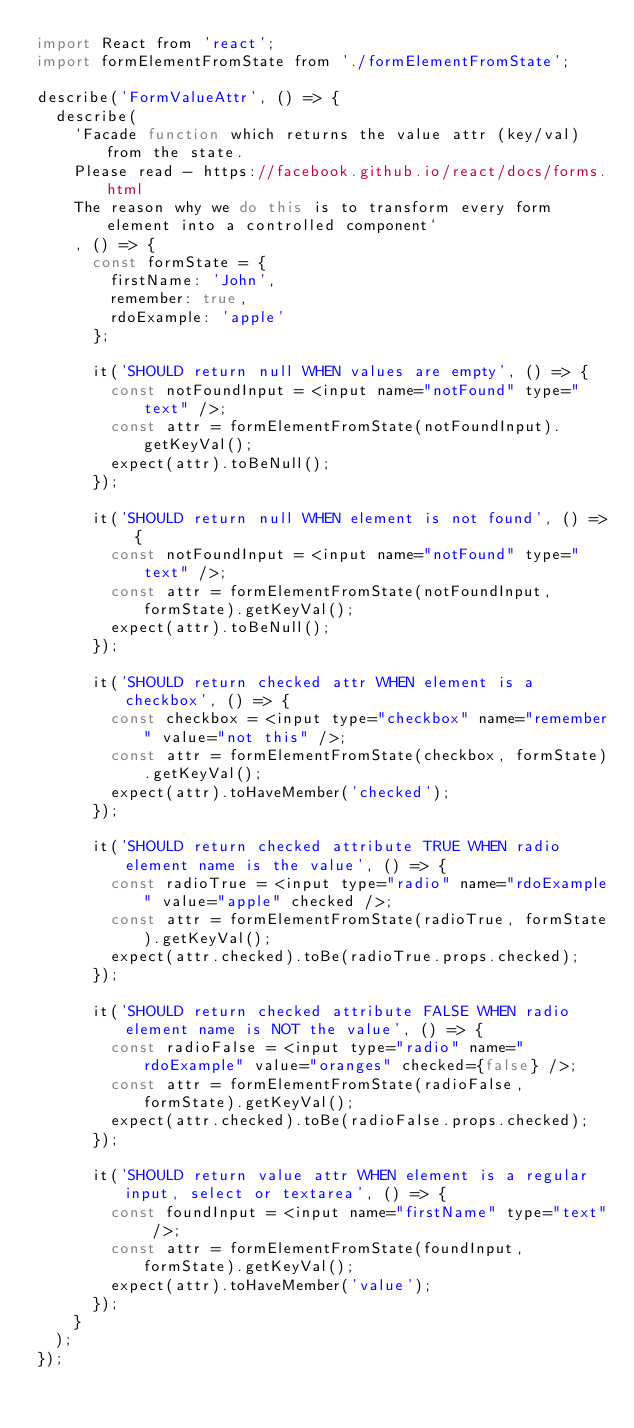<code> <loc_0><loc_0><loc_500><loc_500><_JavaScript_>import React from 'react';
import formElementFromState from './formElementFromState';

describe('FormValueAttr', () => {
  describe(
    `Facade function which returns the value attr (key/val) from the state.
    Please read - https://facebook.github.io/react/docs/forms.html
    The reason why we do this is to transform every form element into a controlled component`
    , () => {
      const formState = {
        firstName: 'John',
        remember: true,
        rdoExample: 'apple'
      };

      it('SHOULD return null WHEN values are empty', () => {
        const notFoundInput = <input name="notFound" type="text" />;
        const attr = formElementFromState(notFoundInput).getKeyVal();
        expect(attr).toBeNull();
      });

      it('SHOULD return null WHEN element is not found', () => {
        const notFoundInput = <input name="notFound" type="text" />;
        const attr = formElementFromState(notFoundInput, formState).getKeyVal();
        expect(attr).toBeNull();
      });

      it('SHOULD return checked attr WHEN element is a checkbox', () => {
        const checkbox = <input type="checkbox" name="remember" value="not this" />;
        const attr = formElementFromState(checkbox, formState).getKeyVal();
        expect(attr).toHaveMember('checked');
      });

      it('SHOULD return checked attribute TRUE WHEN radio element name is the value', () => {
        const radioTrue = <input type="radio" name="rdoExample" value="apple" checked />;
        const attr = formElementFromState(radioTrue, formState).getKeyVal();
        expect(attr.checked).toBe(radioTrue.props.checked);
      });

      it('SHOULD return checked attribute FALSE WHEN radio element name is NOT the value', () => {
        const radioFalse = <input type="radio" name="rdoExample" value="oranges" checked={false} />;
        const attr = formElementFromState(radioFalse, formState).getKeyVal();
        expect(attr.checked).toBe(radioFalse.props.checked);
      });

      it('SHOULD return value attr WHEN element is a regular input, select or textarea', () => {
        const foundInput = <input name="firstName" type="text" />;
        const attr = formElementFromState(foundInput, formState).getKeyVal();
        expect(attr).toHaveMember('value');
      });
    }
  );
});
</code> 